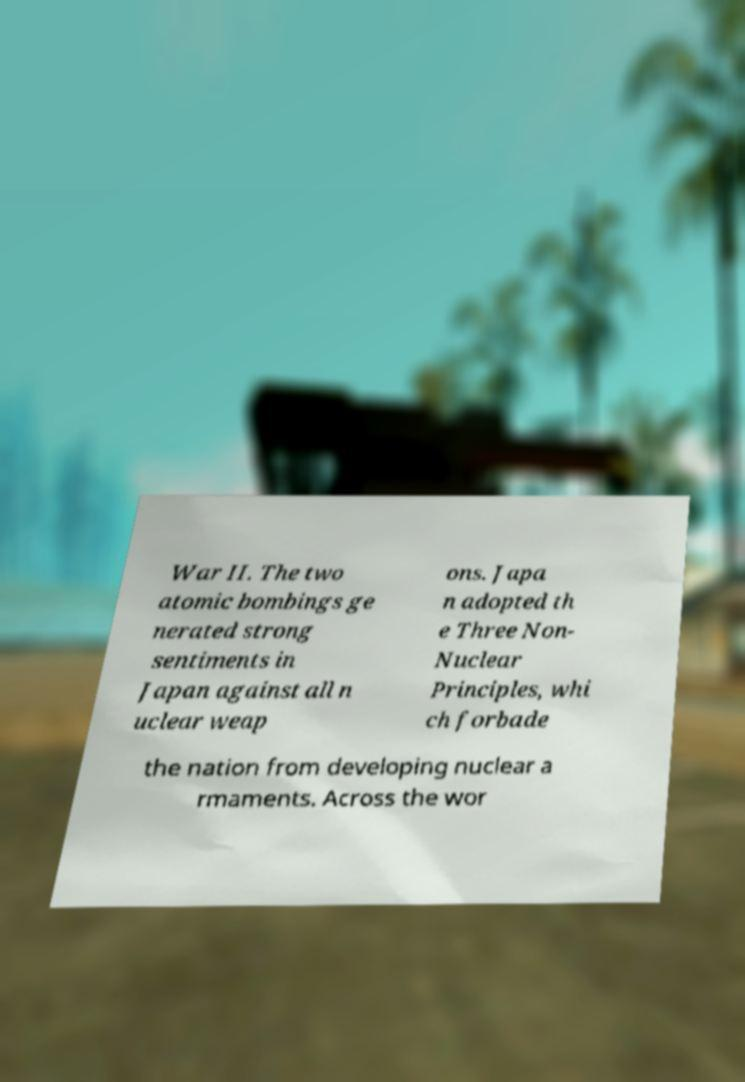Can you accurately transcribe the text from the provided image for me? War II. The two atomic bombings ge nerated strong sentiments in Japan against all n uclear weap ons. Japa n adopted th e Three Non- Nuclear Principles, whi ch forbade the nation from developing nuclear a rmaments. Across the wor 